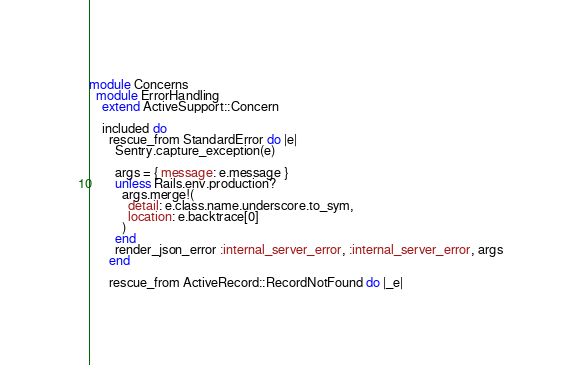<code> <loc_0><loc_0><loc_500><loc_500><_Ruby_>module Concerns
  module ErrorHandling
    extend ActiveSupport::Concern

    included do
      rescue_from StandardError do |e|
        Sentry.capture_exception(e)

        args = { message: e.message }
        unless Rails.env.production?
          args.merge!(
            detail: e.class.name.underscore.to_sym,
            location: e.backtrace[0]
          )
        end
        render_json_error :internal_server_error, :internal_server_error, args
      end

      rescue_from ActiveRecord::RecordNotFound do |_e|</code> 